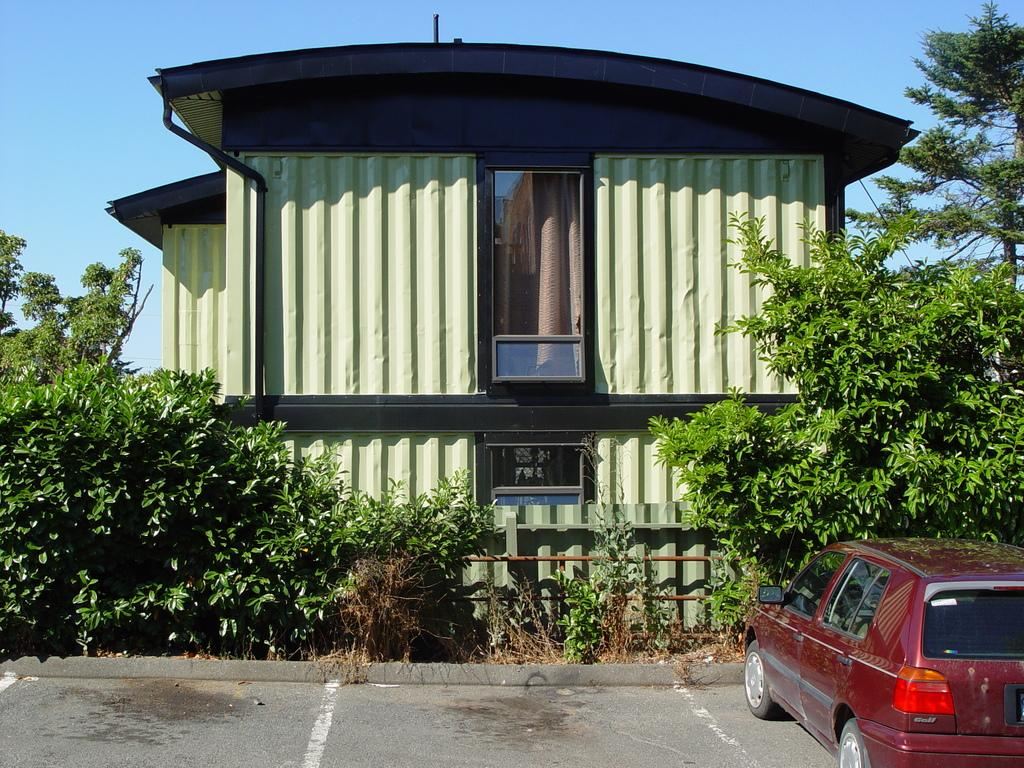What type of structure is visible in the image? There is a building in the image. What natural elements can be seen in the image? There are trees and plants in the image. What type of vehicle is on the right side of the image? There is a red color car on the right side of the image. What markings are present on the road in the image? There are white lines on the road. What is visible in the background of the image? The sky is visible in the background of the image. Where is the dad in the image? There is no dad present in the image. What type of transportation is depicted on the train tracks in the image? There are no train tracks or trains present in the image. What force is responsible for the movement of the car in the image? The question of friction is not relevant to the image, as it does not depict any movement or forces acting on the car. 